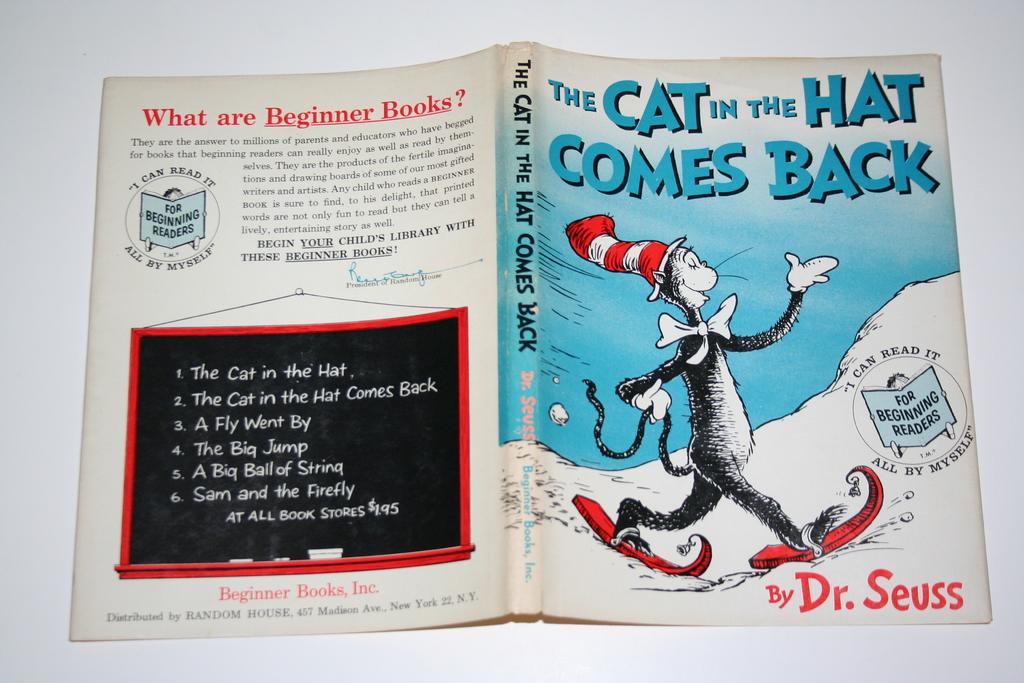What is the name of this book?
Make the answer very short. The cat in the hat comes back. Who wrote this book?
Keep it short and to the point. Dr. seuss. 